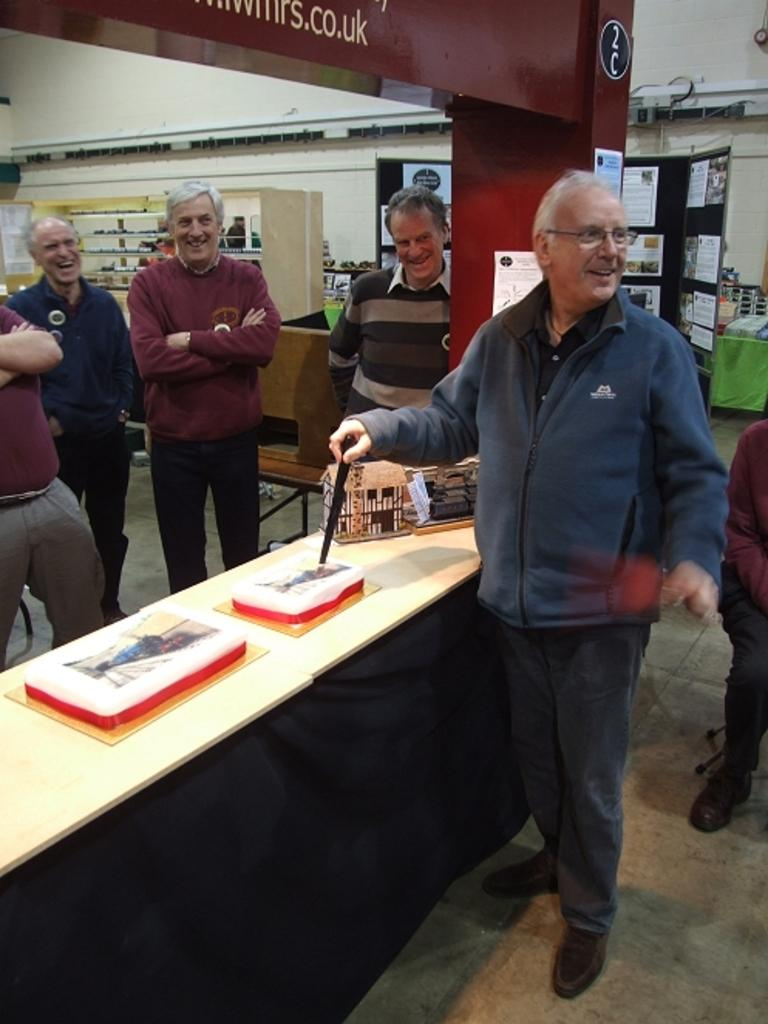What can be seen on the wall in the image? There is a banner on the wall in the image. What is on the board in the image? There are papers on a board in the image. How many people are visible in the image? There are people standing in the image. What is on the table in the image? There are books and a box on the table in the image. What type of wood is used to make the curve in the image? There is no curve made of wood present in the image. Why are the people in the image crying? There is no indication in the image that the people are crying; they are simply standing. 